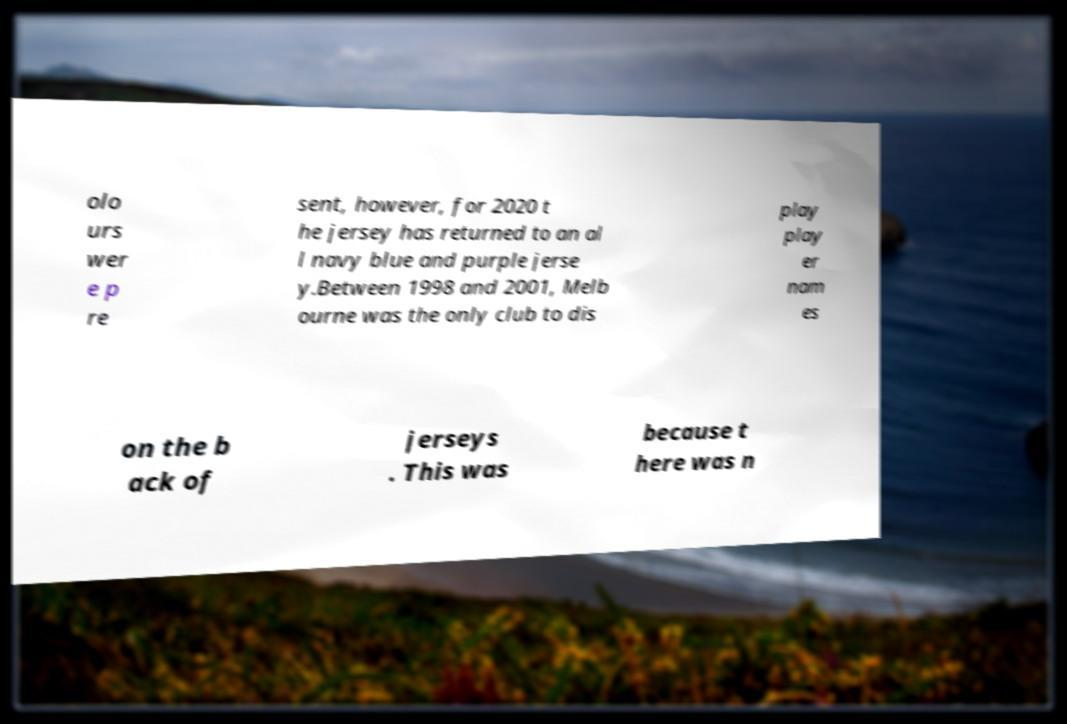There's text embedded in this image that I need extracted. Can you transcribe it verbatim? olo urs wer e p re sent, however, for 2020 t he jersey has returned to an al l navy blue and purple jerse y.Between 1998 and 2001, Melb ourne was the only club to dis play play er nam es on the b ack of jerseys . This was because t here was n 